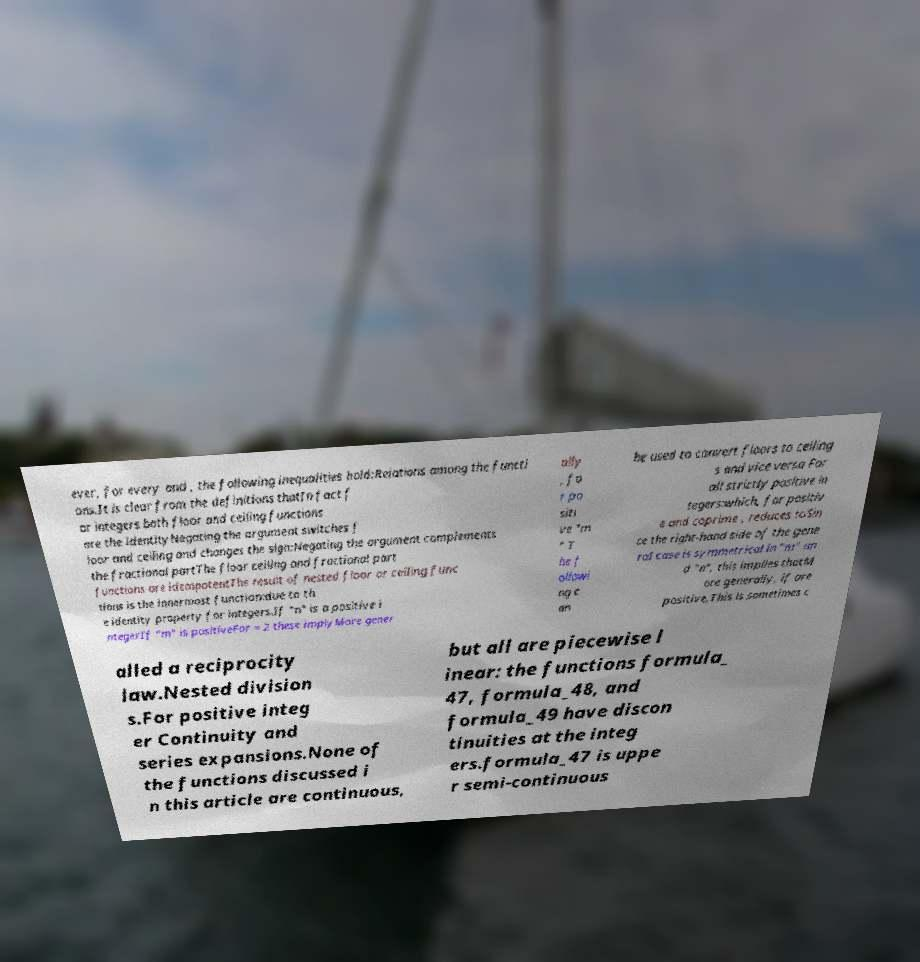I need the written content from this picture converted into text. Can you do that? ever, for every and , the following inequalities hold:Relations among the functi ons.It is clear from the definitions thatIn fact f or integers both floor and ceiling functions are the identityNegating the argument switches f loor and ceiling and changes the sign:Negating the argument complements the fractional partThe floor ceiling and fractional part functions are idempotentThe result of nested floor or ceiling func tions is the innermost function:due to th e identity property for integers.If "n" is a positive i ntegerIf "m" is positiveFor = 2 these implyMore gener ally , fo r po siti ve "m " T he f ollowi ng c an be used to convert floors to ceiling s and vice versa For all strictly positive in tegers:which, for positiv e and coprime , reduces toSin ce the right-hand side of the gene ral case is symmetrical in "m" an d "n", this implies thatM ore generally, if are positive,This is sometimes c alled a reciprocity law.Nested division s.For positive integ er Continuity and series expansions.None of the functions discussed i n this article are continuous, but all are piecewise l inear: the functions formula_ 47, formula_48, and formula_49 have discon tinuities at the integ ers.formula_47 is uppe r semi-continuous 